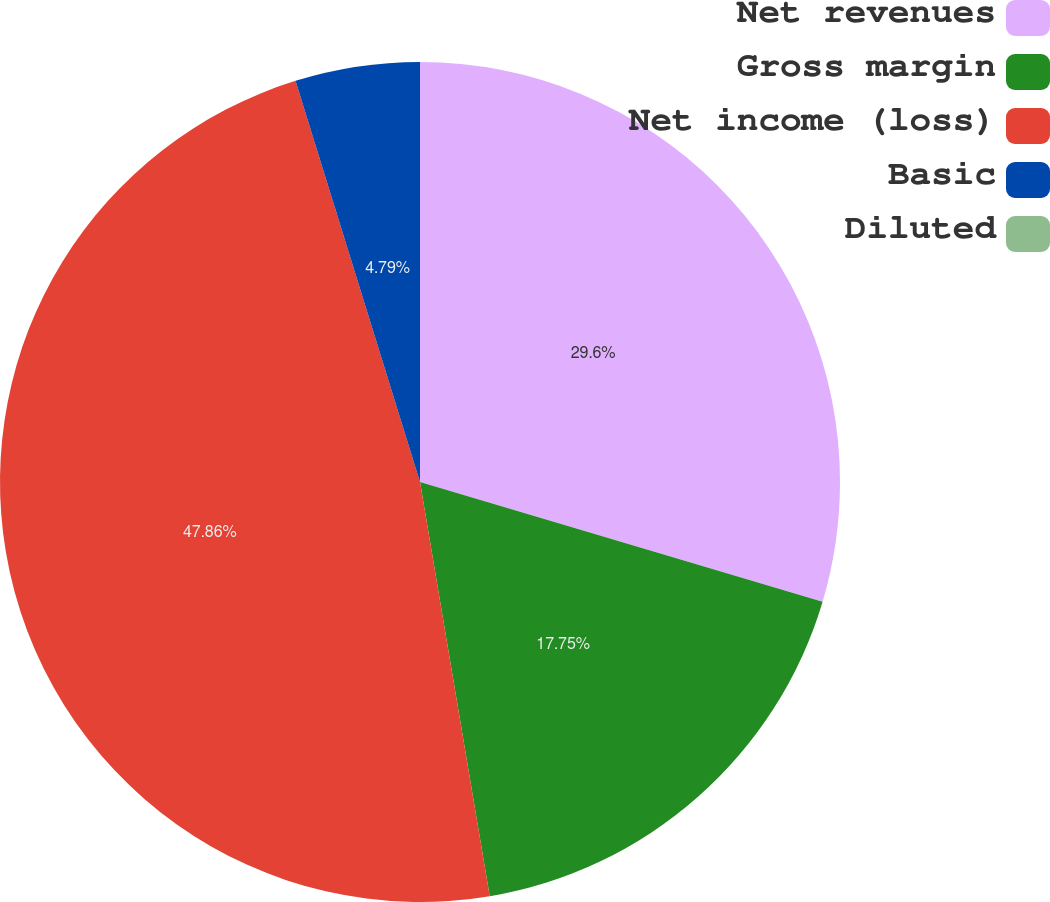Convert chart. <chart><loc_0><loc_0><loc_500><loc_500><pie_chart><fcel>Net revenues<fcel>Gross margin<fcel>Net income (loss)<fcel>Basic<fcel>Diluted<nl><fcel>29.6%<fcel>17.75%<fcel>47.87%<fcel>4.79%<fcel>0.0%<nl></chart> 